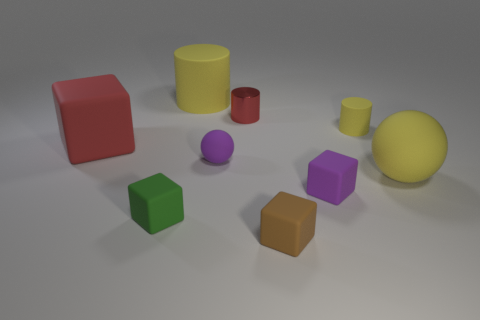Are there more rubber things that are in front of the big red matte block than small purple balls that are behind the small brown matte thing?
Provide a succinct answer. Yes. There is a block that is the same color as the metal cylinder; what size is it?
Give a very brief answer. Large. What color is the small metallic object?
Keep it short and to the point. Red. What color is the big matte object that is both in front of the small yellow matte cylinder and right of the tiny green rubber cube?
Give a very brief answer. Yellow. What color is the cylinder that is right of the tiny cylinder left of the yellow matte cylinder right of the small rubber sphere?
Offer a very short reply. Yellow. What color is the rubber ball that is the same size as the red rubber thing?
Keep it short and to the point. Yellow. What is the shape of the tiny metallic object behind the big rubber thing right of the big yellow rubber thing left of the small matte cylinder?
Give a very brief answer. Cylinder. What is the shape of the rubber object that is the same color as the metallic thing?
Your response must be concise. Cube. What number of things are large blue metal things or purple rubber things on the right side of the tiny red cylinder?
Your response must be concise. 1. There is a red object on the right side of the green cube; is it the same size as the yellow sphere?
Give a very brief answer. No. 